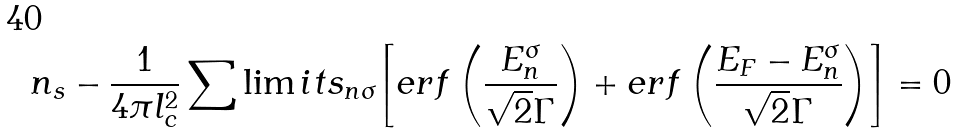Convert formula to latex. <formula><loc_0><loc_0><loc_500><loc_500>n _ { s } - \frac { 1 } { 4 \pi l _ { c } ^ { 2 } } \sum \lim i t s _ { n \sigma } { \left [ { e r f \left ( { \frac { E _ { n } ^ { \sigma } } { \sqrt { 2 } \Gamma } } \right ) + e r f \left ( { \frac { E _ { F } - E _ { n } ^ { \sigma } } { \sqrt { 2 } \Gamma } } \right ) } \right ] } = 0</formula> 